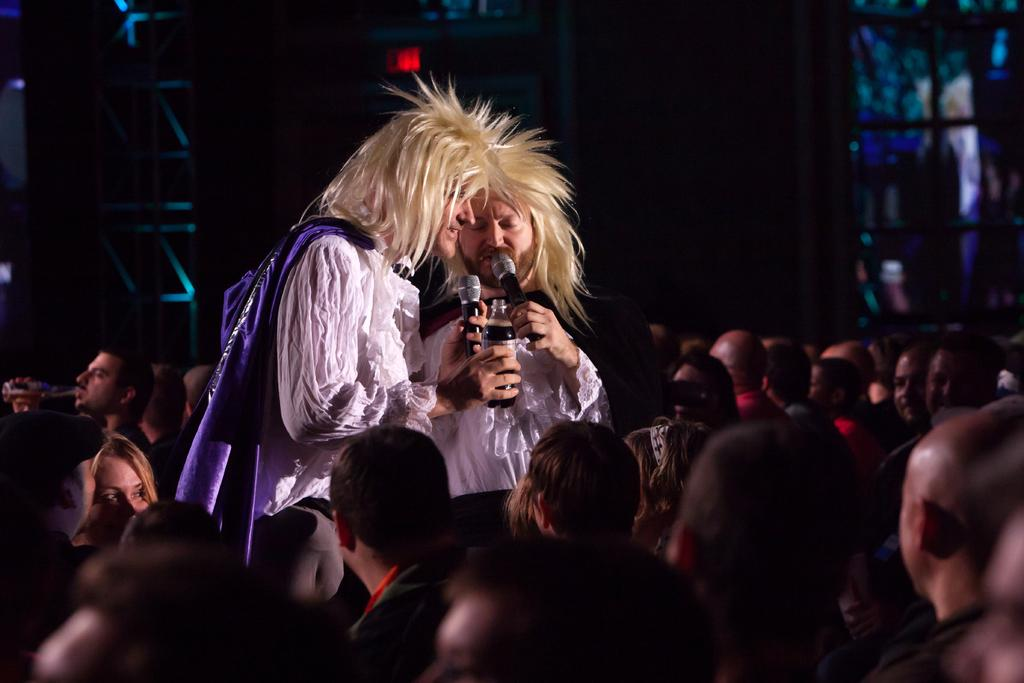How many people are in the image? There are 2 people in the image. What are the people wearing? Both people are wearing white dresses. What are the people holding in their hands? The people are holding microphones in their hands. What else is one person holding? One person is holding a bottle. Can you describe the surrounding environment in the image? There are people surrounding the two individuals. How many ladybugs can be seen on the white dresses in the image? There are no ladybugs visible on the white dresses in the image. What type of yarn is being used by the flock of sheep in the image? There are no sheep or yarn present in the image. 